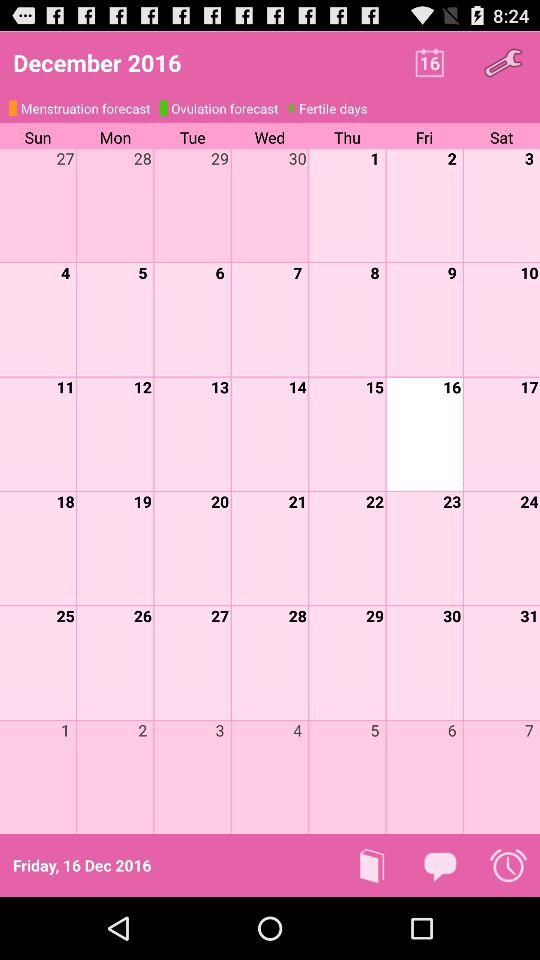Which date is selected? The selected date is Friday, December 16, 2016. 